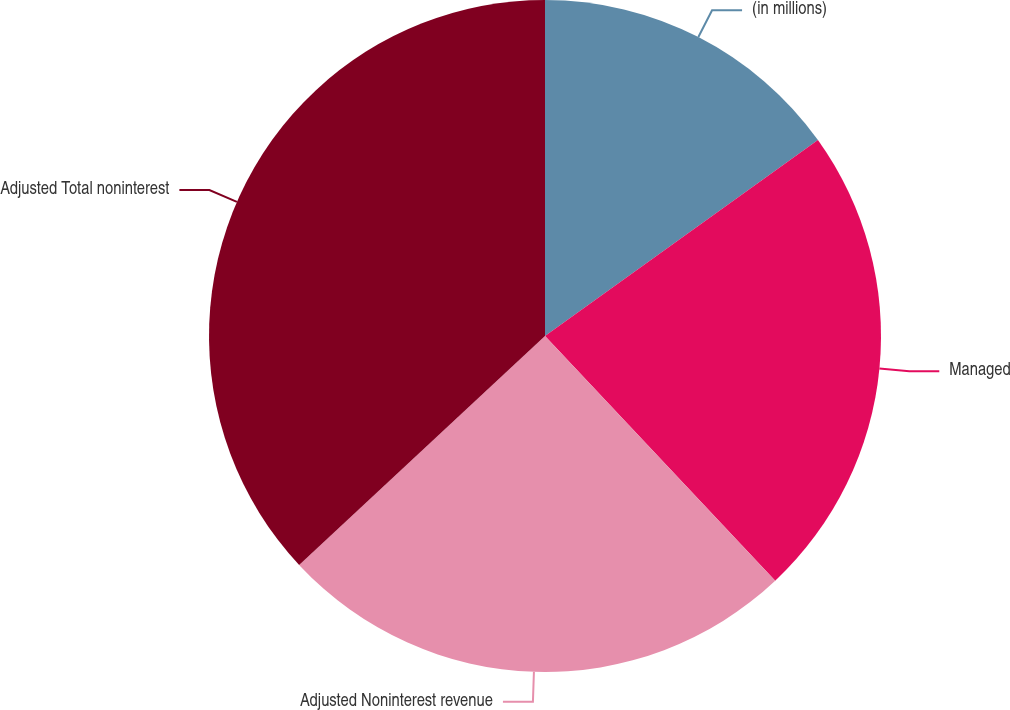Convert chart. <chart><loc_0><loc_0><loc_500><loc_500><pie_chart><fcel>(in millions)<fcel>Managed<fcel>Adjusted Noninterest revenue<fcel>Adjusted Total noninterest<nl><fcel>15.09%<fcel>22.9%<fcel>25.08%<fcel>36.94%<nl></chart> 